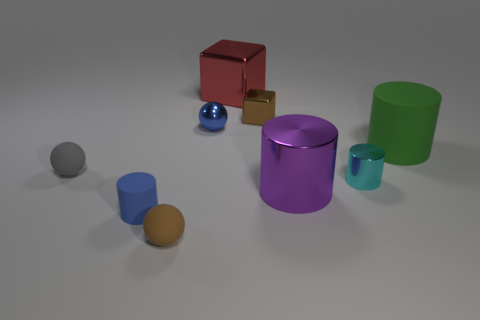What materials do these objects appear to be made of? The objects in the image seem to be made of different materials. The small and large cylinders have a matte finish suggesting a plastic or painted metal, while the cube and the small ball appear to have reflective surfaces that could indicate a metallic or glossy plastic construction. 